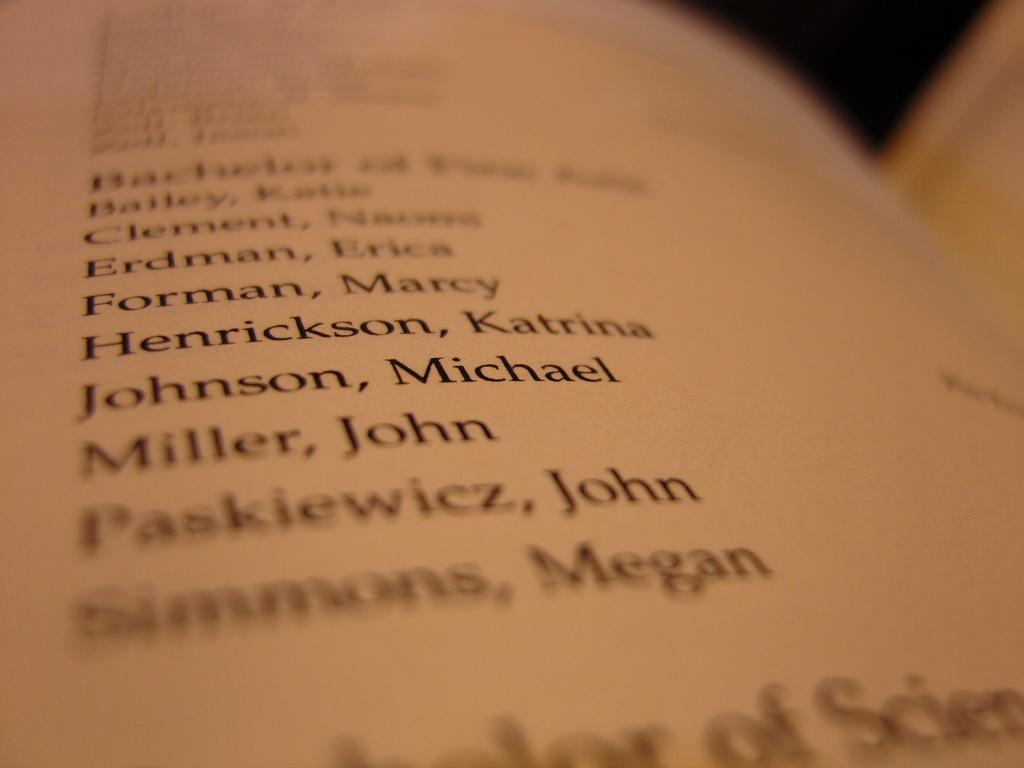<image>
Offer a succinct explanation of the picture presented. A book opened to a page containing a list of names Such as Miller, John. 